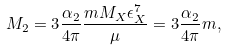<formula> <loc_0><loc_0><loc_500><loc_500>M _ { 2 } = 3 \frac { \alpha _ { 2 } } { 4 \pi } \frac { m M _ { X } \epsilon _ { X } ^ { 7 } } { \mu } = 3 \frac { \alpha _ { 2 } } { 4 \pi } m ,</formula> 